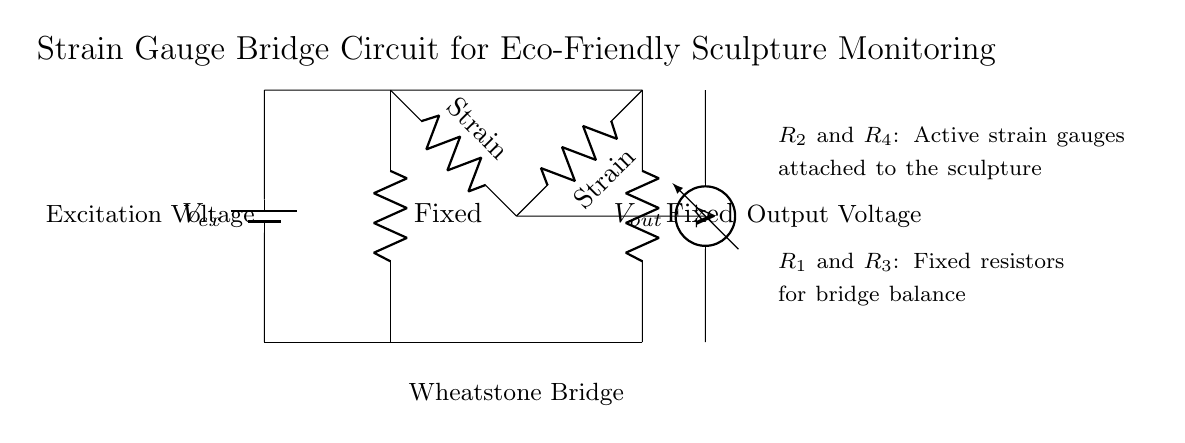What is the excitation voltage in the circuit? The circuit diagram shows a battery labeled V ex, which indicates the source of the excitation voltage. There is no specific numerical value provided, so we refer to it by its label.
Answer: V ex How many strain gauges are present in the bridge circuit? The circuit diagram clearly indicates two resistors labeled as strain gauges, R2 and R4, each connected to the sculpture. Therefore, the total number of strain gauges is two.
Answer: 2 What type of circuit is represented in the diagram? The structure of the circuit with four resistors arranged in a specific format, along with the voltage measurement, identifies this as a wheatstone bridge circuit.
Answer: Wheatstone bridge What role do R1 and R3 play in the circuit? R1 and R3 are labeled as fixed resistors for bridge balance, indicating their function in ensuring the bridge is balanced for accurate measurement of resistance changes in the strain gauges.
Answer: Bridge balance What is V out in the context of this circuit? The circuit includes a voltmeter connected across points where the strain gauges are, measuring the output voltage, which reflects the balance or imbalance in the bridge due to strain.
Answer: Output voltage What happens to V out when the sculpture is under stress? When the sculpture experiences stress, the resistance of the strain gauges R2 and R4 changes, which alters the voltage readings from the voltmeter connected across them, thus changing V out.
Answer: Changes with stress How is the structural integrity of the sculpture monitored? The strain gauges R2 and R4 detect changes in resistance due to deformation of the sculpture, which is then quantified into output voltage readings (V out), indicating structural integrity.
Answer: Through resistance changes 